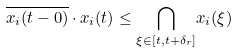<formula> <loc_0><loc_0><loc_500><loc_500>\overline { x _ { i } ( t - 0 ) } \cdot x _ { i } ( t ) \leq \underset { \xi \in [ t , t + \delta _ { r } ] } { \bigcap } x _ { i } ( \xi )</formula> 